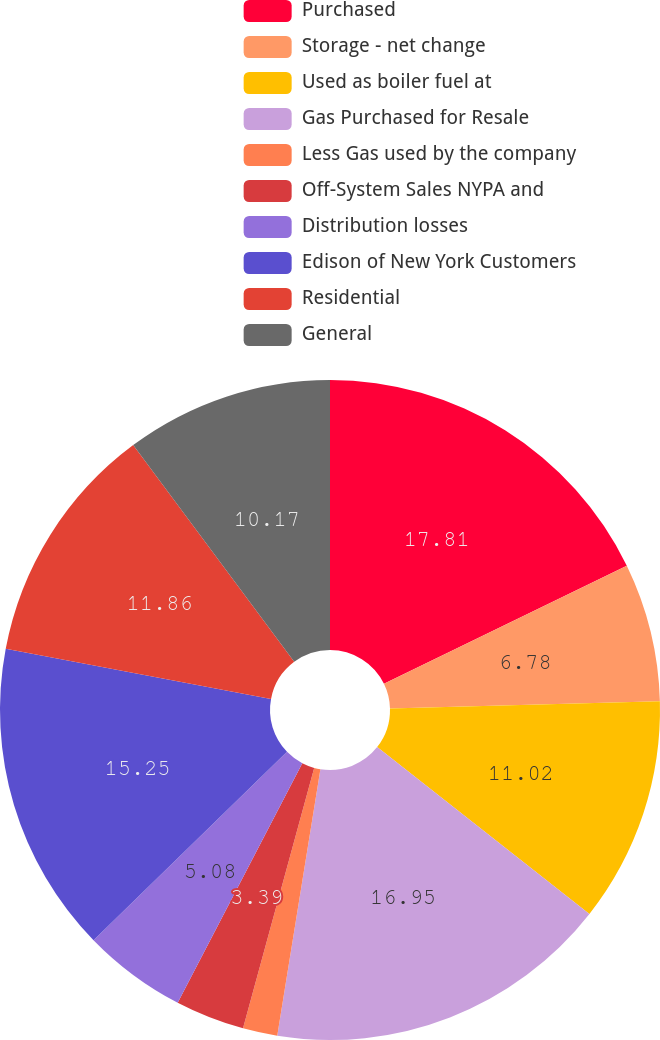Convert chart to OTSL. <chart><loc_0><loc_0><loc_500><loc_500><pie_chart><fcel>Purchased<fcel>Storage - net change<fcel>Used as boiler fuel at<fcel>Gas Purchased for Resale<fcel>Less Gas used by the company<fcel>Off-System Sales NYPA and<fcel>Distribution losses<fcel>Edison of New York Customers<fcel>Residential<fcel>General<nl><fcel>17.8%<fcel>6.78%<fcel>11.02%<fcel>16.95%<fcel>1.69%<fcel>3.39%<fcel>5.08%<fcel>15.25%<fcel>11.86%<fcel>10.17%<nl></chart> 